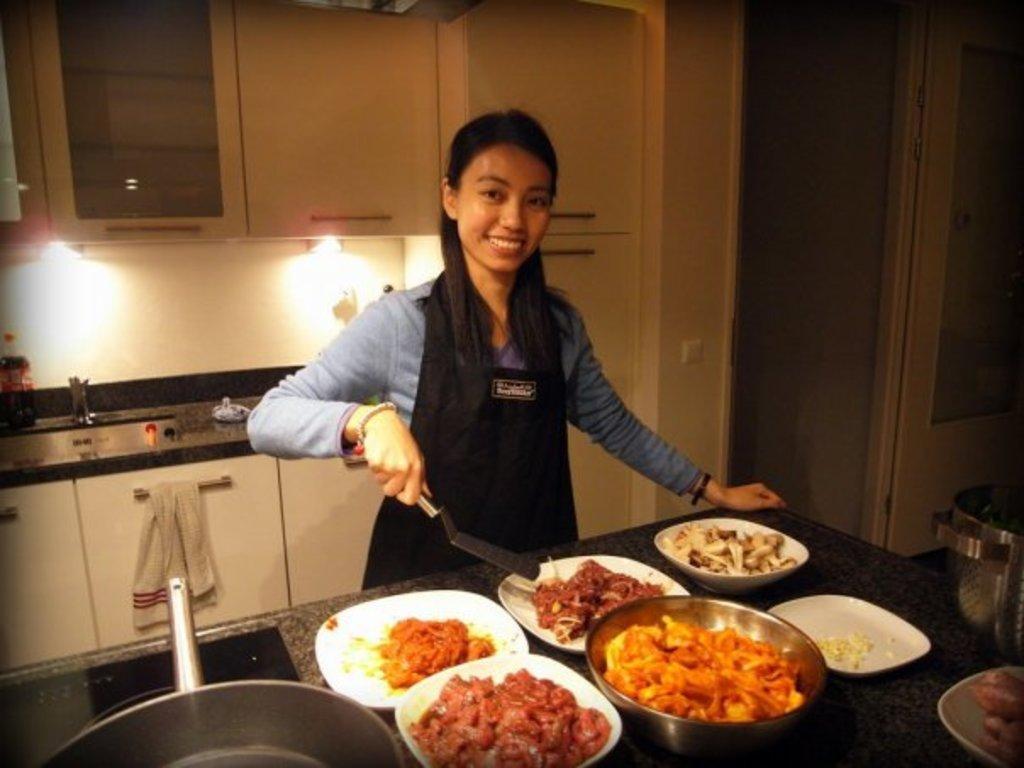Describe this image in one or two sentences. In the center the image we can see a woman standing holding a spatula. We can also see a table in front of her containing a pan and a container. We can also see a bowl and some plates containing food in it. On the backside we can see a table containing a sink and a bottle on it, a towel on a cupboard, a switch board, some lights and a door. 